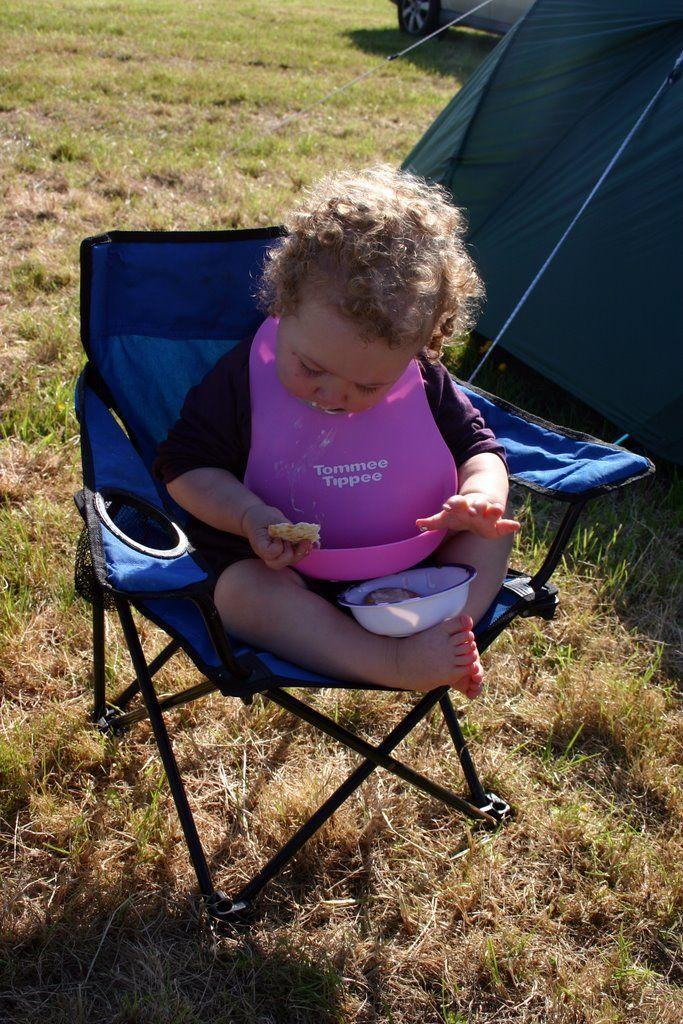What is the main subject of the image? The main subject of the image is a kid. What is the kid doing in the image? The kid is seated on a chair and eating. What can be seen in the background of the image? There is a tent and a vehicle in the background of the image. What type of skirt is the kid wearing in the image? The image does not show the kid wearing a skirt; they are seated on a chair and eating. How many apples can be seen in the image? There are no apples present in the image. 